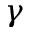Convert formula to latex. <formula><loc_0><loc_0><loc_500><loc_500>\gamma</formula> 